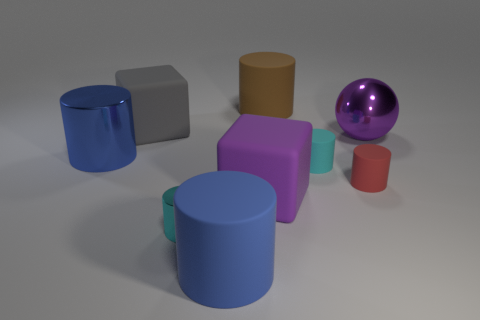Subtract all brown cylinders. How many cylinders are left? 5 Subtract all brown cylinders. How many cylinders are left? 5 Subtract 2 cylinders. How many cylinders are left? 4 Subtract all yellow cylinders. Subtract all purple spheres. How many cylinders are left? 6 Add 1 large shiny balls. How many objects exist? 10 Subtract all cubes. How many objects are left? 7 Subtract all big gray matte cubes. Subtract all rubber cylinders. How many objects are left? 4 Add 1 cyan metallic cylinders. How many cyan metallic cylinders are left? 2 Add 5 small cyan shiny things. How many small cyan shiny things exist? 6 Subtract 1 red cylinders. How many objects are left? 8 